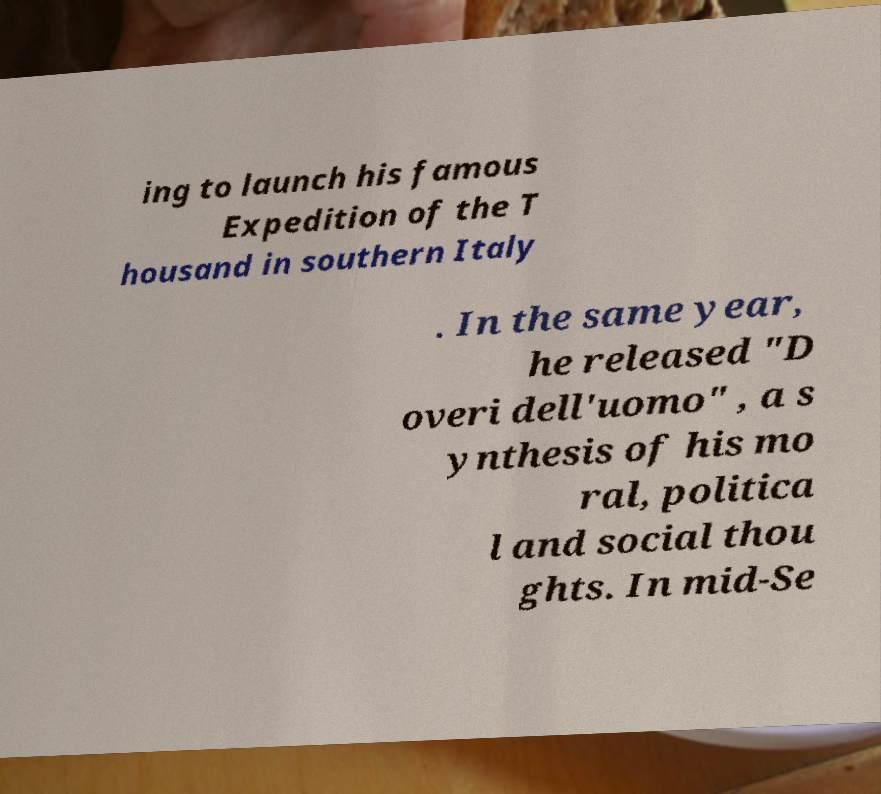Can you accurately transcribe the text from the provided image for me? ing to launch his famous Expedition of the T housand in southern Italy . In the same year, he released "D overi dell'uomo" , a s ynthesis of his mo ral, politica l and social thou ghts. In mid-Se 